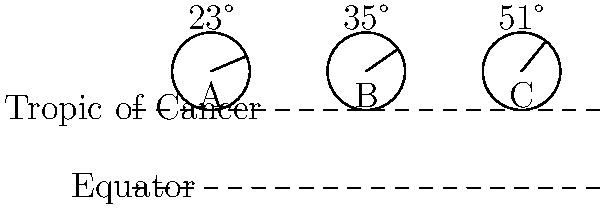Three ancient sundials (A, B, and C) have been discovered with different gnomon angles. Sundial A has an angle of 23°, B has 35°, and C has 51°. Based on your knowledge of historical sundial design and geographical considerations, which sundial is most likely to have originated from a location nearest to the Tropic of Cancer? To determine which sundial originated closest to the Tropic of Cancer, we need to consider the relationship between sundial gnomon angles and latitude:

1. The gnomon angle of a sundial is typically equal to the latitude of its location.
2. The Tropic of Cancer is located at approximately 23.5° North latitude.

Let's analyze each sundial:

1. Sundial A (23°):
   - This angle is very close to 23.5°, the latitude of the Tropic of Cancer.
   
2. Sundial B (35°):
   - This angle suggests a location further north than the Tropic of Cancer.
   
3. Sundial C (51°):
   - This angle indicates an even more northerly location.

Comparing these angles to the latitude of the Tropic of Cancer (23.5°):

$|23° - 23.5°| = 0.5°$
$|35° - 23.5°| = 11.5°$
$|51° - 23.5°| = 27.5°$

Sundial A has the smallest difference from the Tropic of Cancer's latitude.
Answer: Sundial A 